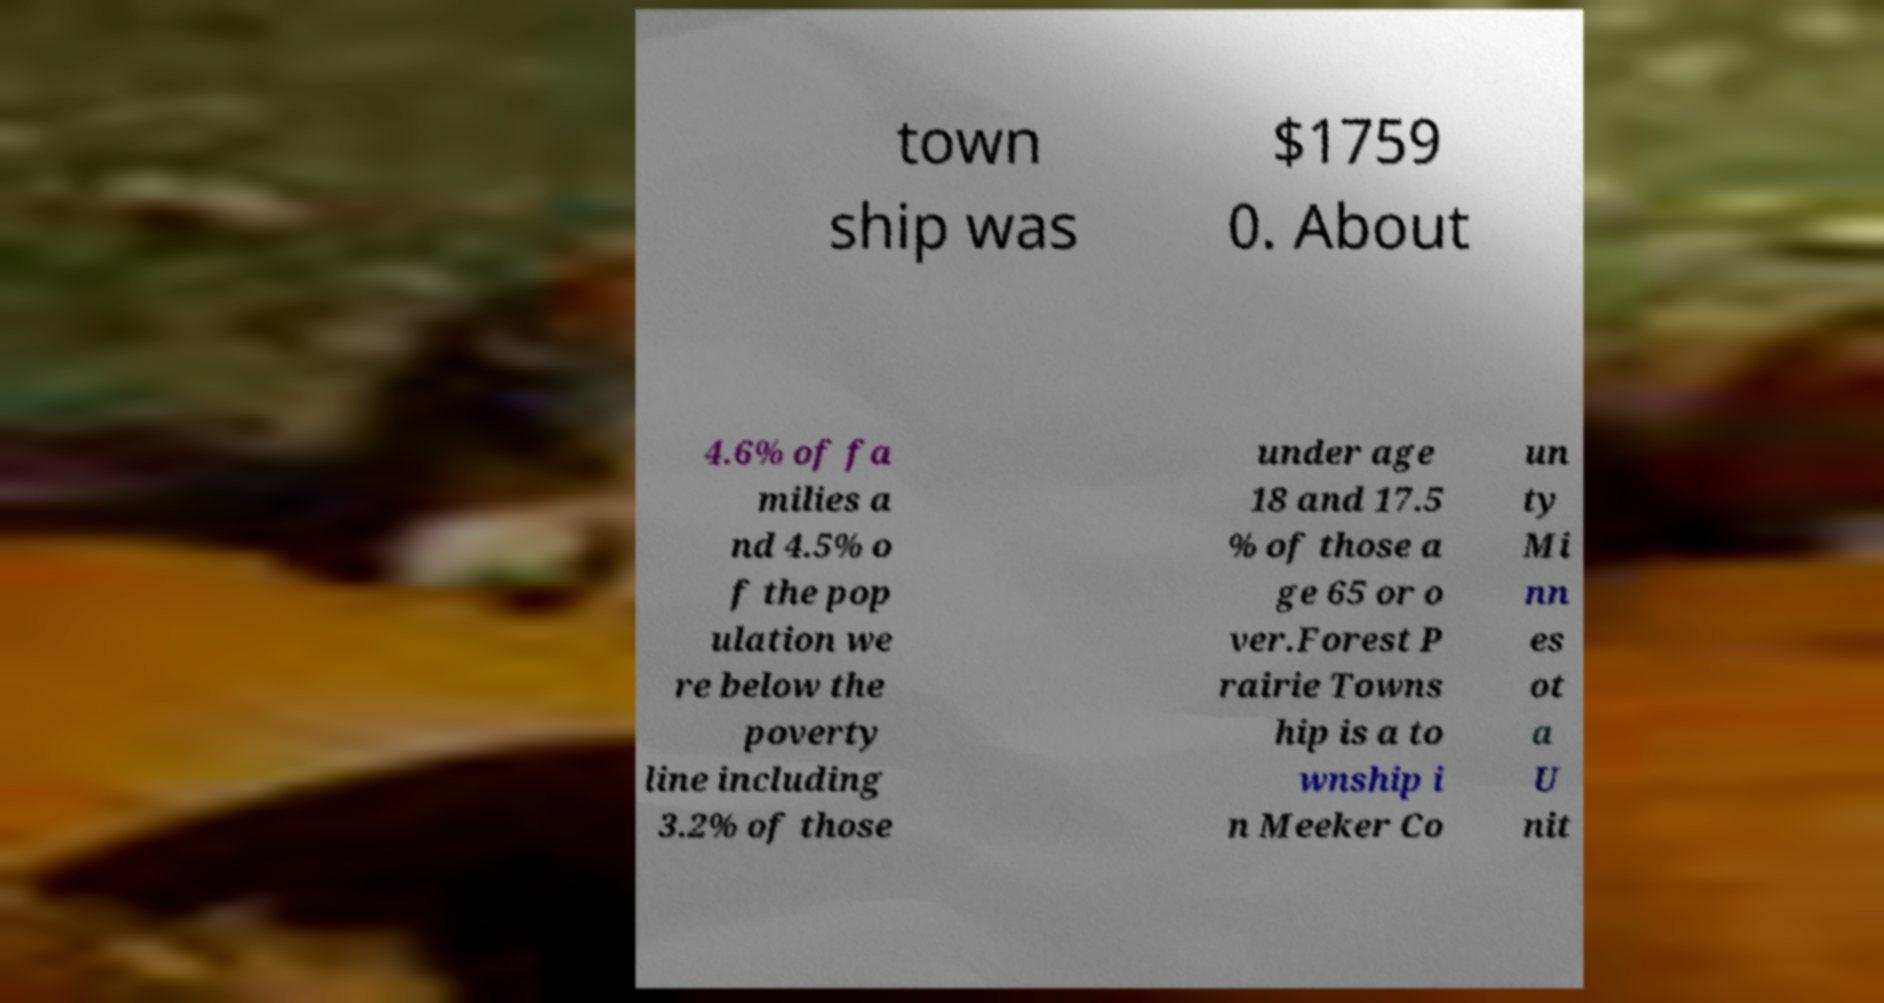I need the written content from this picture converted into text. Can you do that? town ship was $1759 0. About 4.6% of fa milies a nd 4.5% o f the pop ulation we re below the poverty line including 3.2% of those under age 18 and 17.5 % of those a ge 65 or o ver.Forest P rairie Towns hip is a to wnship i n Meeker Co un ty Mi nn es ot a U nit 